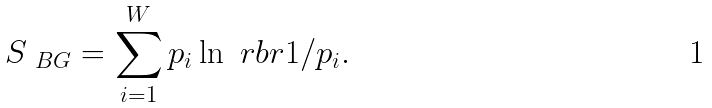<formula> <loc_0><loc_0><loc_500><loc_500>S _ { \ B G } = \sum _ { i = 1 } ^ { W } p _ { i } \ln { \ r b r { 1 / p _ { i } } } .</formula> 